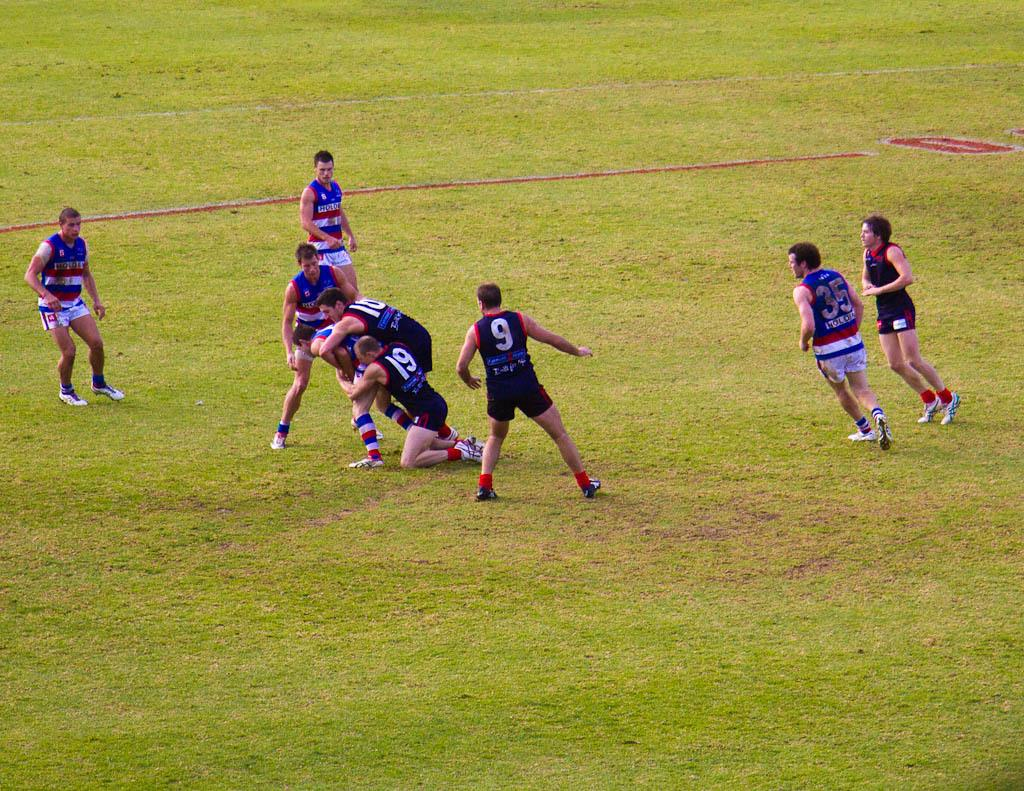What are the persons in the image doing? The persons in the image are playing. Where are the persons located in the image? The persons are in the center of the image. What type of surface is under the persons in the image? There is grass on the ground in the image. What type of bait is being used by the persons in the image? There is no indication of fishing or bait in the image; the persons are playing. How are the persons gripping the objects they are playing with in the image? The image does not provide enough detail to determine how the persons are gripping the objects they are playing with. 